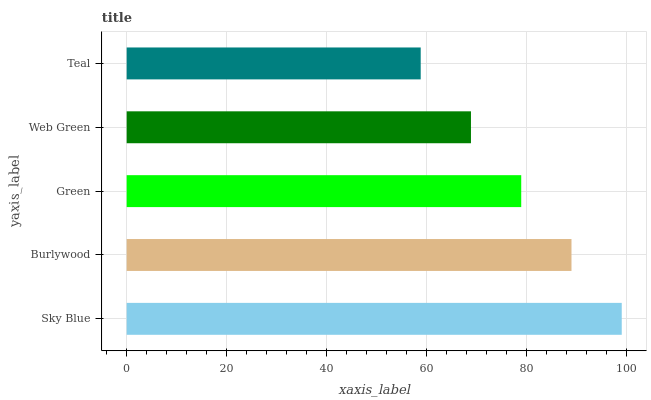Is Teal the minimum?
Answer yes or no. Yes. Is Sky Blue the maximum?
Answer yes or no. Yes. Is Burlywood the minimum?
Answer yes or no. No. Is Burlywood the maximum?
Answer yes or no. No. Is Sky Blue greater than Burlywood?
Answer yes or no. Yes. Is Burlywood less than Sky Blue?
Answer yes or no. Yes. Is Burlywood greater than Sky Blue?
Answer yes or no. No. Is Sky Blue less than Burlywood?
Answer yes or no. No. Is Green the high median?
Answer yes or no. Yes. Is Green the low median?
Answer yes or no. Yes. Is Web Green the high median?
Answer yes or no. No. Is Sky Blue the low median?
Answer yes or no. No. 